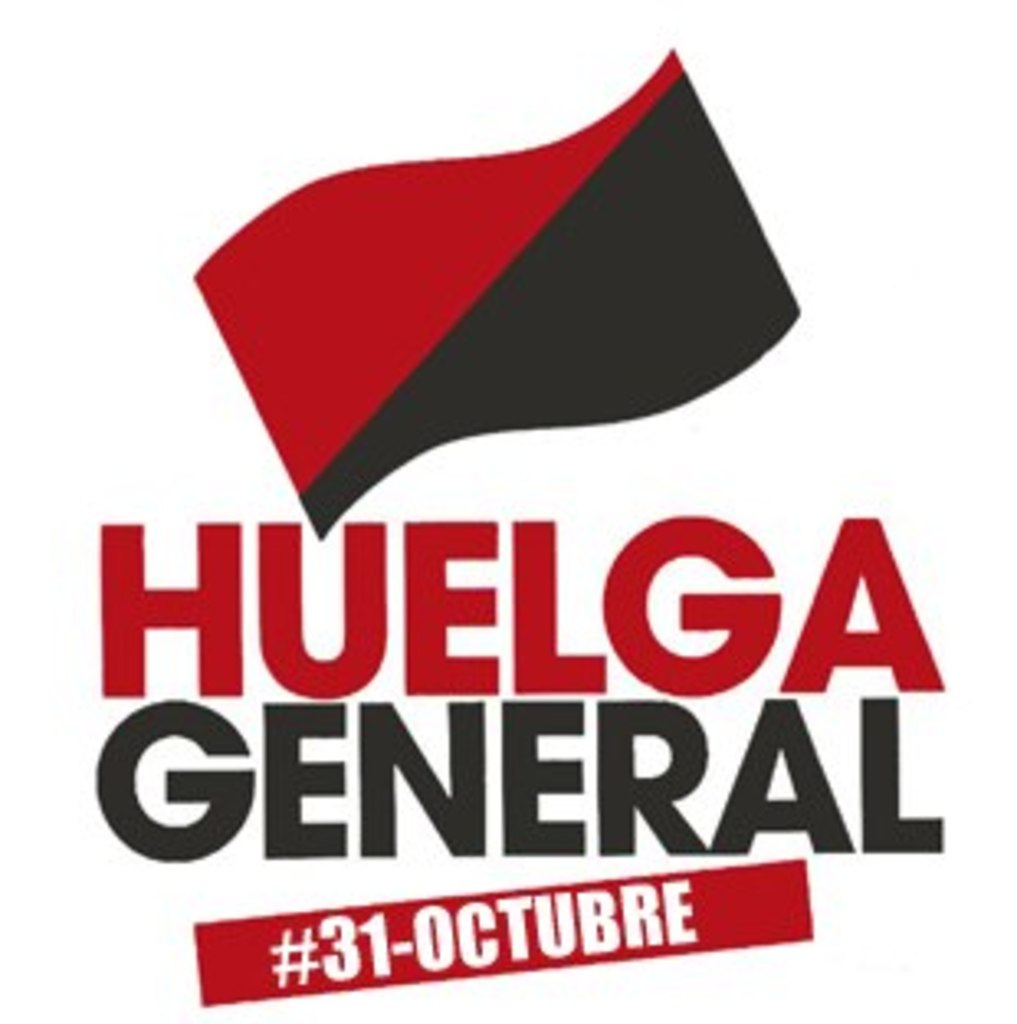What is this photo about? The image in question serves as a powerful poster designed to mobilize support for a general strike, scheduled to occur on October 31st. It prominently features a red and black flag, which is historically associated with anarchist and socialist movements, symbolizing both defiance and solidarity among workers. The bold red text, 'HUELGA GENERAL', translates to 'GENERAL STRIKE' from Spanish, signifying a call to action for workers to unite and halt their labor as a form of protest. The phrase '#31-OCTUBRE' underlines the specific date, making this not only a piece of visual art but also an urgent communiqu� aimed at raising awareness and rallying public support for significant labor action. Understanding the use of such imagery and text can provide insights into the broader labor movement strategies and the collective efforts to effect socio-economic changes. 